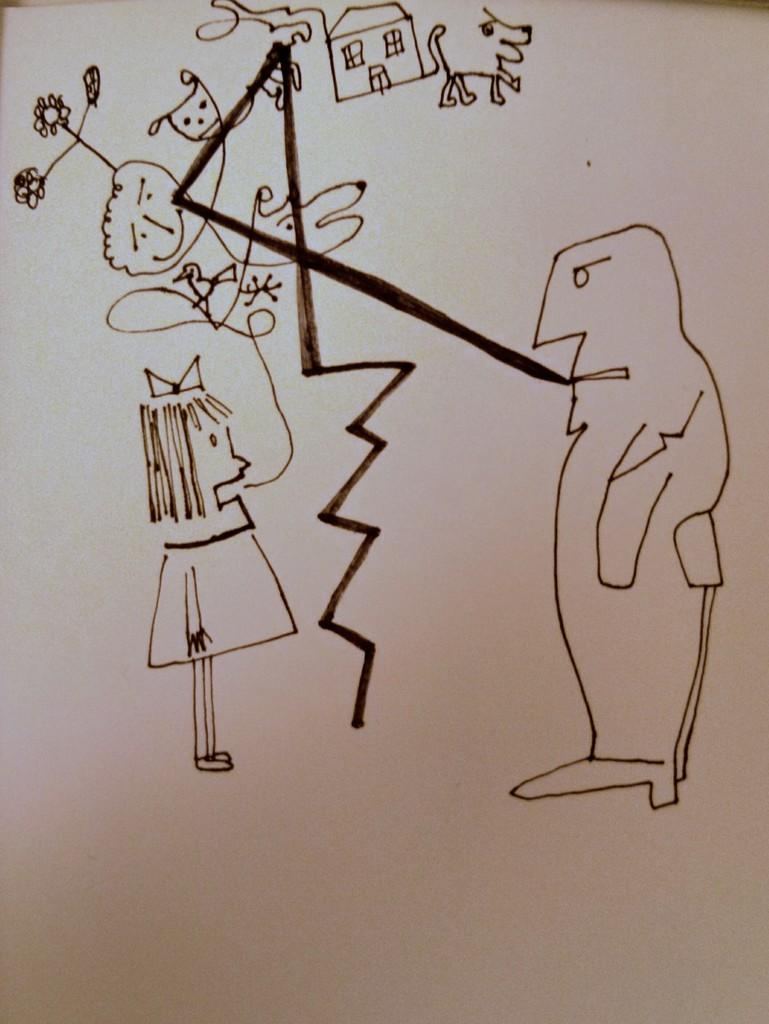What is the main subject of the image? The main subject of the image is a paper. What is depicted on the paper? The paper has a drawing of some cartoons. How many eggs are present in the image? There are no eggs present in the image; it features a paper with a drawing of cartoons. What type of sleep can be seen in the image? There is no sleep depicted in the image; it features a paper with a drawing of cartoons. 